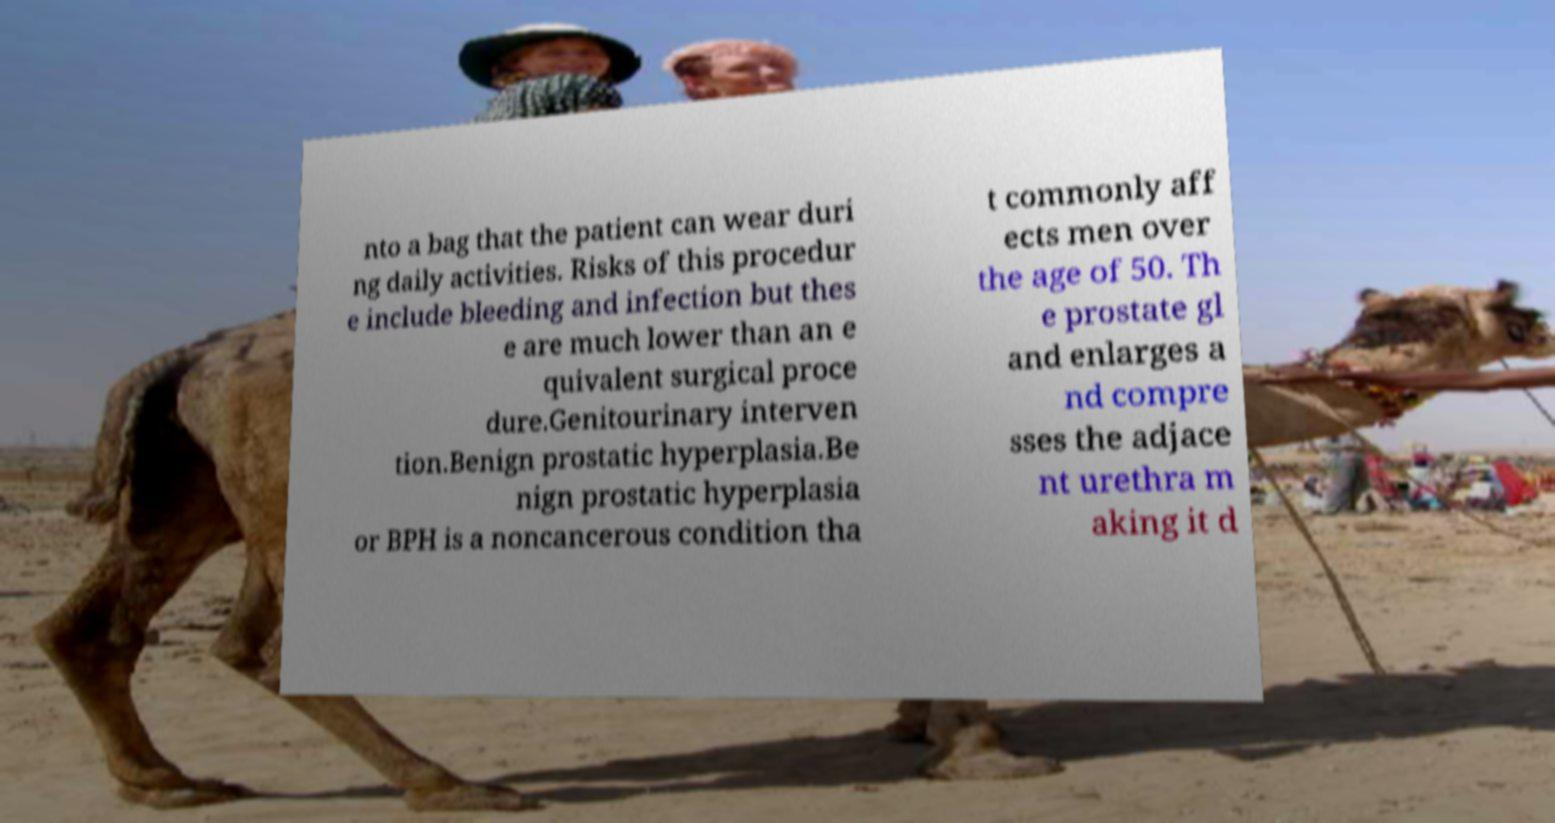I need the written content from this picture converted into text. Can you do that? nto a bag that the patient can wear duri ng daily activities. Risks of this procedur e include bleeding and infection but thes e are much lower than an e quivalent surgical proce dure.Genitourinary interven tion.Benign prostatic hyperplasia.Be nign prostatic hyperplasia or BPH is a noncancerous condition tha t commonly aff ects men over the age of 50. Th e prostate gl and enlarges a nd compre sses the adjace nt urethra m aking it d 